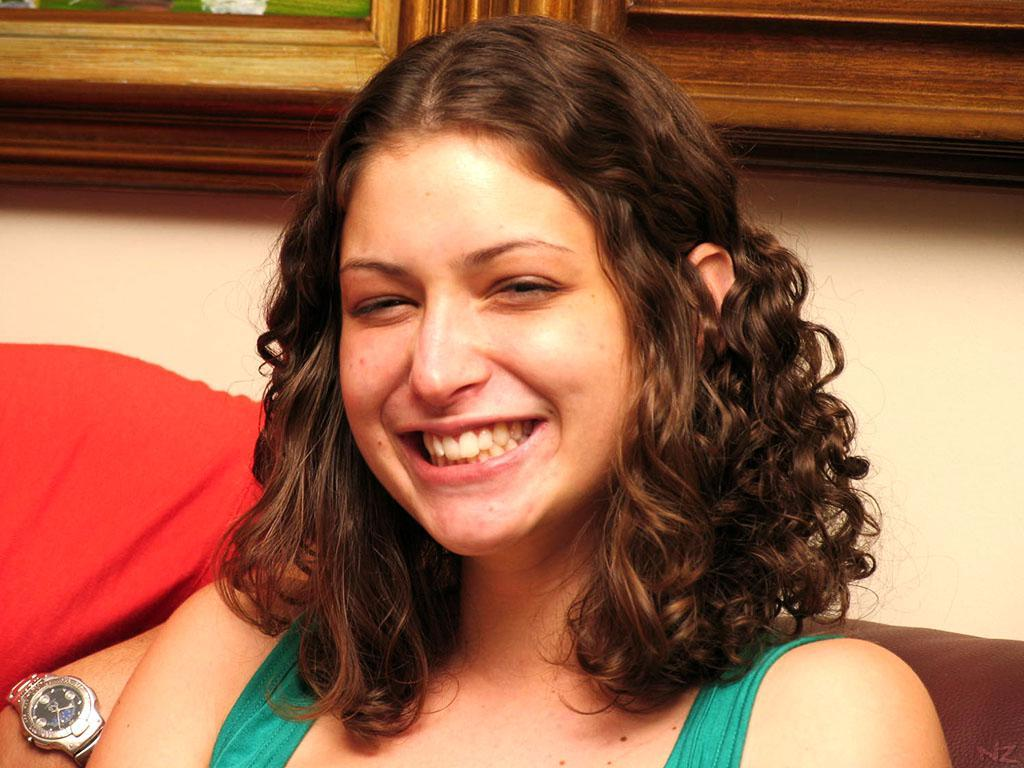Who is present in the image? There is a woman in the image. What is the woman doing in the image? The woman is laughing. Can you see a rabbit in the image? No, there is no rabbit present in the image. Is there a volcano in the background of the image? No, there is no volcano in the image. What invention is the woman holding in the image? There is no invention visible in the image; the woman is simply laughing. 